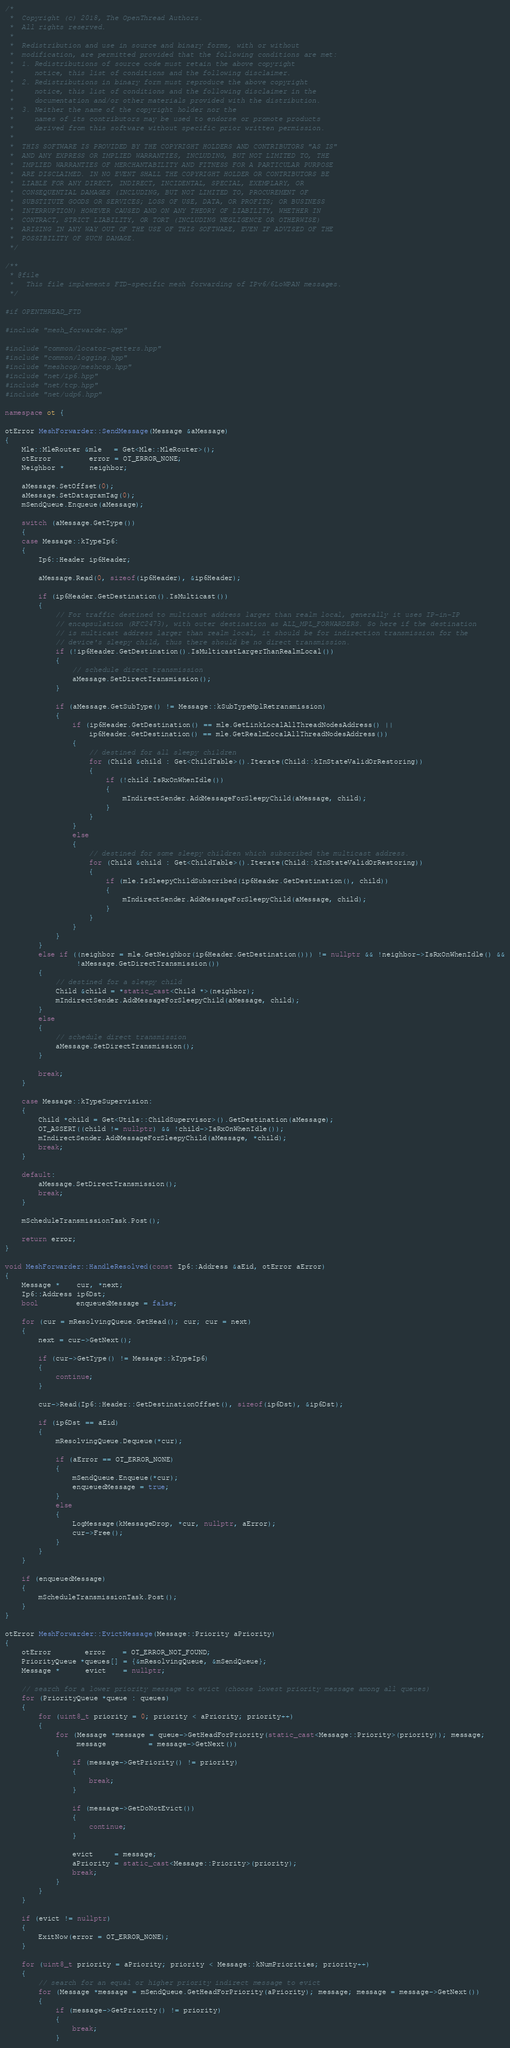Convert code to text. <code><loc_0><loc_0><loc_500><loc_500><_C++_>/*
 *  Copyright (c) 2018, The OpenThread Authors.
 *  All rights reserved.
 *
 *  Redistribution and use in source and binary forms, with or without
 *  modification, are permitted provided that the following conditions are met:
 *  1. Redistributions of source code must retain the above copyright
 *     notice, this list of conditions and the following disclaimer.
 *  2. Redistributions in binary form must reproduce the above copyright
 *     notice, this list of conditions and the following disclaimer in the
 *     documentation and/or other materials provided with the distribution.
 *  3. Neither the name of the copyright holder nor the
 *     names of its contributors may be used to endorse or promote products
 *     derived from this software without specific prior written permission.
 *
 *  THIS SOFTWARE IS PROVIDED BY THE COPYRIGHT HOLDERS AND CONTRIBUTORS "AS IS"
 *  AND ANY EXPRESS OR IMPLIED WARRANTIES, INCLUDING, BUT NOT LIMITED TO, THE
 *  IMPLIED WARRANTIES OF MERCHANTABILITY AND FITNESS FOR A PARTICULAR PURPOSE
 *  ARE DISCLAIMED. IN NO EVENT SHALL THE COPYRIGHT HOLDER OR CONTRIBUTORS BE
 *  LIABLE FOR ANY DIRECT, INDIRECT, INCIDENTAL, SPECIAL, EXEMPLARY, OR
 *  CONSEQUENTIAL DAMAGES (INCLUDING, BUT NOT LIMITED TO, PROCUREMENT OF
 *  SUBSTITUTE GOODS OR SERVICES; LOSS OF USE, DATA, OR PROFITS; OR BUSINESS
 *  INTERRUPTION) HOWEVER CAUSED AND ON ANY THEORY OF LIABILITY, WHETHER IN
 *  CONTRACT, STRICT LIABILITY, OR TORT (INCLUDING NEGLIGENCE OR OTHERWISE)
 *  ARISING IN ANY WAY OUT OF THE USE OF THIS SOFTWARE, EVEN IF ADVISED OF THE
 *  POSSIBILITY OF SUCH DAMAGE.
 */

/**
 * @file
 *   This file implements FTD-specific mesh forwarding of IPv6/6LoWPAN messages.
 */

#if OPENTHREAD_FTD

#include "mesh_forwarder.hpp"

#include "common/locator-getters.hpp"
#include "common/logging.hpp"
#include "meshcop/meshcop.hpp"
#include "net/ip6.hpp"
#include "net/tcp.hpp"
#include "net/udp6.hpp"

namespace ot {

otError MeshForwarder::SendMessage(Message &aMessage)
{
    Mle::MleRouter &mle   = Get<Mle::MleRouter>();
    otError         error = OT_ERROR_NONE;
    Neighbor *      neighbor;

    aMessage.SetOffset(0);
    aMessage.SetDatagramTag(0);
    mSendQueue.Enqueue(aMessage);

    switch (aMessage.GetType())
    {
    case Message::kTypeIp6:
    {
        Ip6::Header ip6Header;

        aMessage.Read(0, sizeof(ip6Header), &ip6Header);

        if (ip6Header.GetDestination().IsMulticast())
        {
            // For traffic destined to multicast address larger than realm local, generally it uses IP-in-IP
            // encapsulation (RFC2473), with outer destination as ALL_MPL_FORWARDERS. So here if the destination
            // is multicast address larger than realm local, it should be for indirection transmission for the
            // device's sleepy child, thus there should be no direct transmission.
            if (!ip6Header.GetDestination().IsMulticastLargerThanRealmLocal())
            {
                // schedule direct transmission
                aMessage.SetDirectTransmission();
            }

            if (aMessage.GetSubType() != Message::kSubTypeMplRetransmission)
            {
                if (ip6Header.GetDestination() == mle.GetLinkLocalAllThreadNodesAddress() ||
                    ip6Header.GetDestination() == mle.GetRealmLocalAllThreadNodesAddress())
                {
                    // destined for all sleepy children
                    for (Child &child : Get<ChildTable>().Iterate(Child::kInStateValidOrRestoring))
                    {
                        if (!child.IsRxOnWhenIdle())
                        {
                            mIndirectSender.AddMessageForSleepyChild(aMessage, child);
                        }
                    }
                }
                else
                {
                    // destined for some sleepy children which subscribed the multicast address.
                    for (Child &child : Get<ChildTable>().Iterate(Child::kInStateValidOrRestoring))
                    {
                        if (mle.IsSleepyChildSubscribed(ip6Header.GetDestination(), child))
                        {
                            mIndirectSender.AddMessageForSleepyChild(aMessage, child);
                        }
                    }
                }
            }
        }
        else if ((neighbor = mle.GetNeighbor(ip6Header.GetDestination())) != nullptr && !neighbor->IsRxOnWhenIdle() &&
                 !aMessage.GetDirectTransmission())
        {
            // destined for a sleepy child
            Child &child = *static_cast<Child *>(neighbor);
            mIndirectSender.AddMessageForSleepyChild(aMessage, child);
        }
        else
        {
            // schedule direct transmission
            aMessage.SetDirectTransmission();
        }

        break;
    }

    case Message::kTypeSupervision:
    {
        Child *child = Get<Utils::ChildSupervisor>().GetDestination(aMessage);
        OT_ASSERT((child != nullptr) && !child->IsRxOnWhenIdle());
        mIndirectSender.AddMessageForSleepyChild(aMessage, *child);
        break;
    }

    default:
        aMessage.SetDirectTransmission();
        break;
    }

    mScheduleTransmissionTask.Post();

    return error;
}

void MeshForwarder::HandleResolved(const Ip6::Address &aEid, otError aError)
{
    Message *    cur, *next;
    Ip6::Address ip6Dst;
    bool         enqueuedMessage = false;

    for (cur = mResolvingQueue.GetHead(); cur; cur = next)
    {
        next = cur->GetNext();

        if (cur->GetType() != Message::kTypeIp6)
        {
            continue;
        }

        cur->Read(Ip6::Header::GetDestinationOffset(), sizeof(ip6Dst), &ip6Dst);

        if (ip6Dst == aEid)
        {
            mResolvingQueue.Dequeue(*cur);

            if (aError == OT_ERROR_NONE)
            {
                mSendQueue.Enqueue(*cur);
                enqueuedMessage = true;
            }
            else
            {
                LogMessage(kMessageDrop, *cur, nullptr, aError);
                cur->Free();
            }
        }
    }

    if (enqueuedMessage)
    {
        mScheduleTransmissionTask.Post();
    }
}

otError MeshForwarder::EvictMessage(Message::Priority aPriority)
{
    otError        error    = OT_ERROR_NOT_FOUND;
    PriorityQueue *queues[] = {&mResolvingQueue, &mSendQueue};
    Message *      evict    = nullptr;

    // search for a lower priority message to evict (choose lowest priority message among all queues)
    for (PriorityQueue *queue : queues)
    {
        for (uint8_t priority = 0; priority < aPriority; priority++)
        {
            for (Message *message = queue->GetHeadForPriority(static_cast<Message::Priority>(priority)); message;
                 message          = message->GetNext())
            {
                if (message->GetPriority() != priority)
                {
                    break;
                }

                if (message->GetDoNotEvict())
                {
                    continue;
                }

                evict     = message;
                aPriority = static_cast<Message::Priority>(priority);
                break;
            }
        }
    }

    if (evict != nullptr)
    {
        ExitNow(error = OT_ERROR_NONE);
    }

    for (uint8_t priority = aPriority; priority < Message::kNumPriorities; priority++)
    {
        // search for an equal or higher priority indirect message to evict
        for (Message *message = mSendQueue.GetHeadForPriority(aPriority); message; message = message->GetNext())
        {
            if (message->GetPriority() != priority)
            {
                break;
            }
</code> 